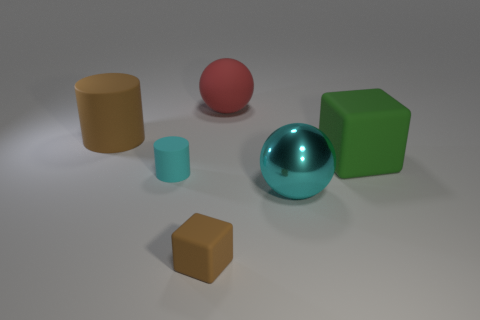What number of metallic things have the same shape as the tiny brown rubber thing?
Ensure brevity in your answer.  0. How many big red balls are there?
Provide a short and direct response. 1. What is the color of the big matte thing that is behind the big brown matte object?
Provide a short and direct response. Red. What color is the big matte object that is on the left side of the large object behind the brown rubber cylinder?
Your answer should be compact. Brown. There is a cylinder that is the same size as the green matte cube; what color is it?
Provide a short and direct response. Brown. How many objects are behind the tiny cyan cylinder and right of the large brown thing?
Your response must be concise. 2. What is the shape of the tiny object that is the same color as the big metal ball?
Keep it short and to the point. Cylinder. What is the material of the thing that is both to the left of the cyan metal ball and in front of the cyan matte cylinder?
Your answer should be very brief. Rubber. Is the number of green cubes to the left of the cyan cylinder less than the number of large balls in front of the big green matte block?
Your answer should be very brief. Yes. What is the size of the green block that is made of the same material as the large brown cylinder?
Provide a short and direct response. Large. 